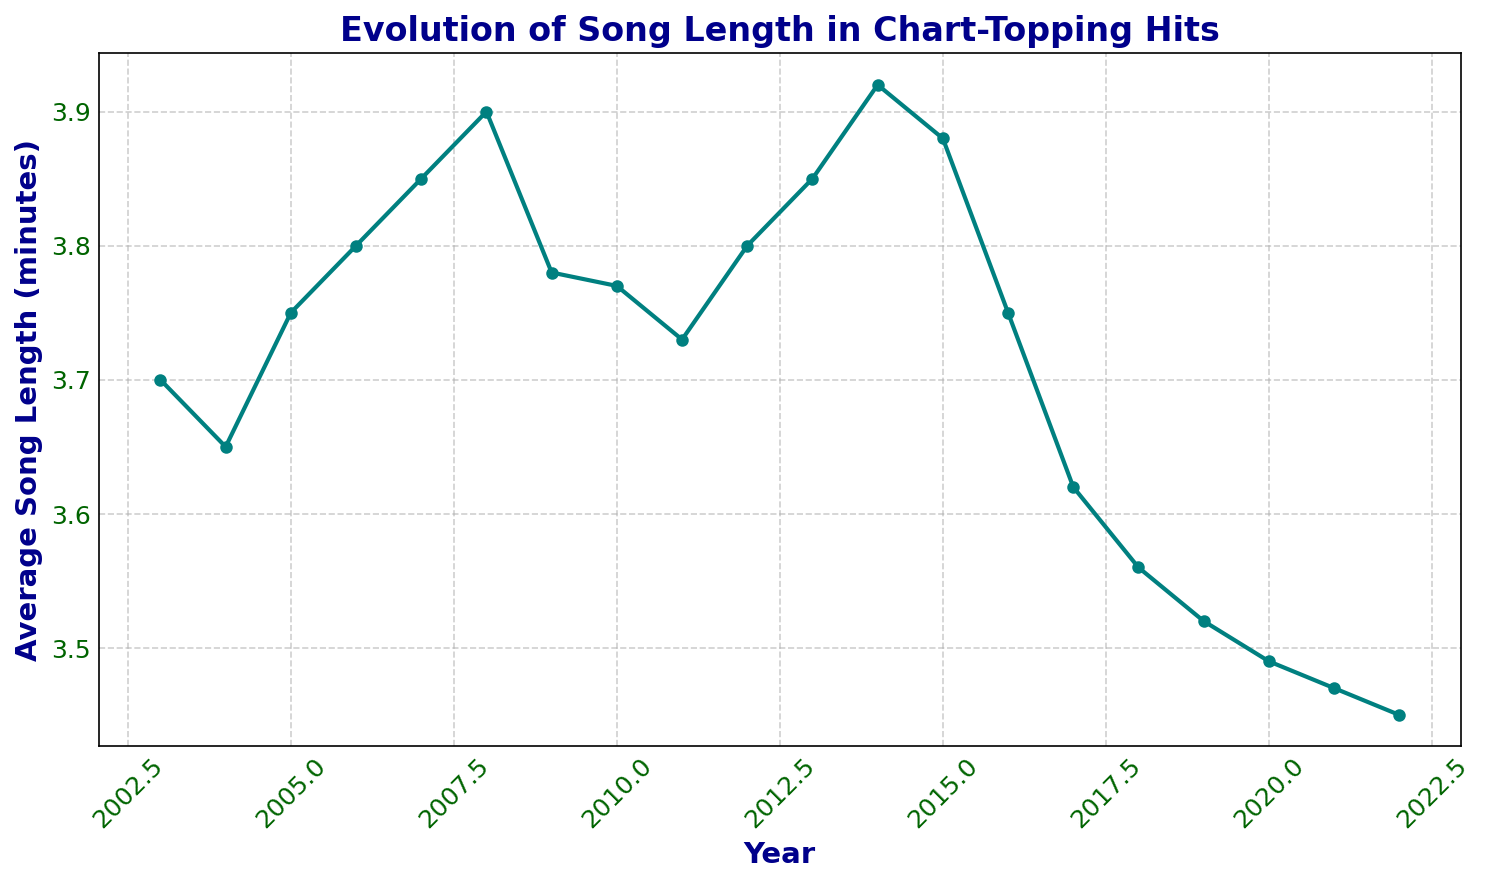Which year had the longest average song length? The line chart shows the song lengths for each year from 2003 to 2022. The highest point on the chart represents the longest average song length.
Answer: 2014 What is the overall trend in average song lengths from 2003 to 2022? Observing the chart, song lengths increase from 2003 to 2014 and then decrease steadily from 2014 to 2022.
Answer: Increase then decrease Which year had a larger average song length, 2008 or 2020? Locate the points for 2008 and 2020 on the chart and compare their values.
Answer: 2008 What is the difference in average song length between 2013 and 2022? The chart shows the average song length for 2013 is 3.85 minutes and 2022 is 3.45 minutes. Subtracting these values gives the difference.
Answer: 0.4 minutes What was the average song length in 2009 and did it increase or decrease the following year? Find the value for 2009, which is 3.78 minutes. The value for 2010 is 3.77 minutes, which is a decrease.
Answer: 3.78 minutes, decrease Which period (years) had the steepest decline in average song length? The steepest decline can be identified by where the slope of the line on the chart is the most negative. The period from 2016 to 2019 shows the steepest decline.
Answer: 2016-2019 What was the average song length in 2007, and how does it compare to 2022? The chart shows the average song length for 2007 is 3.85 minutes and for 2022 it is 3.45 minutes. Comparing these, 2007 had a longer average song length.
Answer: 2007 had a longer average length How many years had an average song length greater than or equal to 3.8 minutes? Count the number of years in which the average song length, as shown on the chart, is 3.8 minutes or more.
Answer: 7 years Between 2003 and 2010, which year experienced the highest increase in average song length? Identify the points from 2003 to 2010 on the chart and calculate the change in song length for each year. The year with the highest positive change will have the highest increase.
Answer: 2006 How does the average song length in 2015 compare to the average in 2017? The chart shows that the average for 2015 is 3.88 minutes, and for 2017, it is 3.62 minutes. Comparing these, 2015 has a longer average song length.
Answer: 2015 is longer 